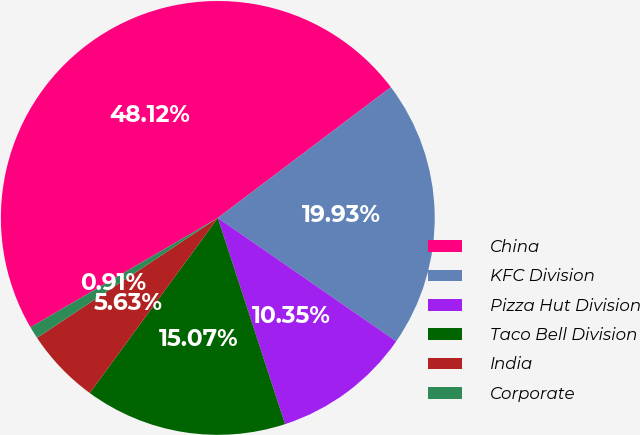Convert chart to OTSL. <chart><loc_0><loc_0><loc_500><loc_500><pie_chart><fcel>China<fcel>KFC Division<fcel>Pizza Hut Division<fcel>Taco Bell Division<fcel>India<fcel>Corporate<nl><fcel>48.12%<fcel>19.93%<fcel>10.35%<fcel>15.07%<fcel>5.63%<fcel>0.91%<nl></chart> 